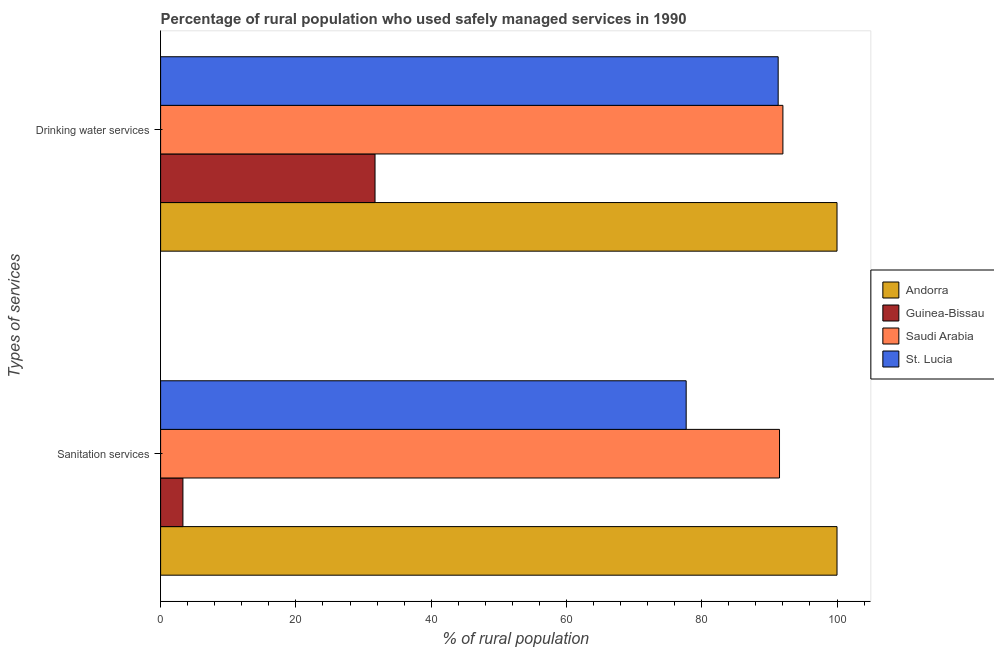How many different coloured bars are there?
Your answer should be very brief. 4. Are the number of bars per tick equal to the number of legend labels?
Provide a short and direct response. Yes. Are the number of bars on each tick of the Y-axis equal?
Keep it short and to the point. Yes. How many bars are there on the 2nd tick from the top?
Offer a very short reply. 4. How many bars are there on the 2nd tick from the bottom?
Your answer should be compact. 4. What is the label of the 1st group of bars from the top?
Your answer should be compact. Drinking water services. What is the percentage of rural population who used drinking water services in St. Lucia?
Provide a succinct answer. 91.3. Across all countries, what is the minimum percentage of rural population who used drinking water services?
Provide a short and direct response. 31.7. In which country was the percentage of rural population who used sanitation services maximum?
Offer a terse response. Andorra. In which country was the percentage of rural population who used sanitation services minimum?
Give a very brief answer. Guinea-Bissau. What is the total percentage of rural population who used sanitation services in the graph?
Give a very brief answer. 272.5. What is the difference between the percentage of rural population who used sanitation services in Andorra and that in Guinea-Bissau?
Your answer should be compact. 96.7. What is the difference between the percentage of rural population who used sanitation services in Saudi Arabia and the percentage of rural population who used drinking water services in Guinea-Bissau?
Give a very brief answer. 59.8. What is the average percentage of rural population who used drinking water services per country?
Provide a short and direct response. 78.75. What is the difference between the percentage of rural population who used drinking water services and percentage of rural population who used sanitation services in Saudi Arabia?
Offer a terse response. 0.5. Is the percentage of rural population who used drinking water services in Guinea-Bissau less than that in Saudi Arabia?
Offer a terse response. Yes. What does the 1st bar from the top in Sanitation services represents?
Give a very brief answer. St. Lucia. What does the 4th bar from the bottom in Sanitation services represents?
Offer a very short reply. St. Lucia. How many bars are there?
Keep it short and to the point. 8. Are all the bars in the graph horizontal?
Make the answer very short. Yes. Does the graph contain grids?
Give a very brief answer. No. Where does the legend appear in the graph?
Offer a very short reply. Center right. How are the legend labels stacked?
Ensure brevity in your answer.  Vertical. What is the title of the graph?
Your answer should be very brief. Percentage of rural population who used safely managed services in 1990. What is the label or title of the X-axis?
Offer a terse response. % of rural population. What is the label or title of the Y-axis?
Ensure brevity in your answer.  Types of services. What is the % of rural population of Andorra in Sanitation services?
Provide a short and direct response. 100. What is the % of rural population of Saudi Arabia in Sanitation services?
Keep it short and to the point. 91.5. What is the % of rural population in St. Lucia in Sanitation services?
Give a very brief answer. 77.7. What is the % of rural population of Guinea-Bissau in Drinking water services?
Ensure brevity in your answer.  31.7. What is the % of rural population in Saudi Arabia in Drinking water services?
Provide a succinct answer. 92. What is the % of rural population of St. Lucia in Drinking water services?
Make the answer very short. 91.3. Across all Types of services, what is the maximum % of rural population in Andorra?
Provide a short and direct response. 100. Across all Types of services, what is the maximum % of rural population of Guinea-Bissau?
Your answer should be compact. 31.7. Across all Types of services, what is the maximum % of rural population of Saudi Arabia?
Make the answer very short. 92. Across all Types of services, what is the maximum % of rural population in St. Lucia?
Keep it short and to the point. 91.3. Across all Types of services, what is the minimum % of rural population in Guinea-Bissau?
Keep it short and to the point. 3.3. Across all Types of services, what is the minimum % of rural population of Saudi Arabia?
Provide a succinct answer. 91.5. Across all Types of services, what is the minimum % of rural population of St. Lucia?
Offer a very short reply. 77.7. What is the total % of rural population in Andorra in the graph?
Keep it short and to the point. 200. What is the total % of rural population in Saudi Arabia in the graph?
Provide a short and direct response. 183.5. What is the total % of rural population in St. Lucia in the graph?
Give a very brief answer. 169. What is the difference between the % of rural population in Andorra in Sanitation services and that in Drinking water services?
Your answer should be very brief. 0. What is the difference between the % of rural population in Guinea-Bissau in Sanitation services and that in Drinking water services?
Provide a succinct answer. -28.4. What is the difference between the % of rural population in Saudi Arabia in Sanitation services and that in Drinking water services?
Your answer should be very brief. -0.5. What is the difference between the % of rural population of St. Lucia in Sanitation services and that in Drinking water services?
Your response must be concise. -13.6. What is the difference between the % of rural population of Andorra in Sanitation services and the % of rural population of Guinea-Bissau in Drinking water services?
Provide a succinct answer. 68.3. What is the difference between the % of rural population of Andorra in Sanitation services and the % of rural population of Saudi Arabia in Drinking water services?
Your response must be concise. 8. What is the difference between the % of rural population of Andorra in Sanitation services and the % of rural population of St. Lucia in Drinking water services?
Your answer should be compact. 8.7. What is the difference between the % of rural population of Guinea-Bissau in Sanitation services and the % of rural population of Saudi Arabia in Drinking water services?
Offer a very short reply. -88.7. What is the difference between the % of rural population in Guinea-Bissau in Sanitation services and the % of rural population in St. Lucia in Drinking water services?
Your answer should be compact. -88. What is the difference between the % of rural population of Saudi Arabia in Sanitation services and the % of rural population of St. Lucia in Drinking water services?
Provide a succinct answer. 0.2. What is the average % of rural population in Andorra per Types of services?
Ensure brevity in your answer.  100. What is the average % of rural population of Guinea-Bissau per Types of services?
Provide a succinct answer. 17.5. What is the average % of rural population in Saudi Arabia per Types of services?
Offer a terse response. 91.75. What is the average % of rural population in St. Lucia per Types of services?
Make the answer very short. 84.5. What is the difference between the % of rural population in Andorra and % of rural population in Guinea-Bissau in Sanitation services?
Provide a short and direct response. 96.7. What is the difference between the % of rural population of Andorra and % of rural population of Saudi Arabia in Sanitation services?
Keep it short and to the point. 8.5. What is the difference between the % of rural population of Andorra and % of rural population of St. Lucia in Sanitation services?
Your response must be concise. 22.3. What is the difference between the % of rural population in Guinea-Bissau and % of rural population in Saudi Arabia in Sanitation services?
Give a very brief answer. -88.2. What is the difference between the % of rural population in Guinea-Bissau and % of rural population in St. Lucia in Sanitation services?
Your answer should be compact. -74.4. What is the difference between the % of rural population of Andorra and % of rural population of Guinea-Bissau in Drinking water services?
Make the answer very short. 68.3. What is the difference between the % of rural population in Guinea-Bissau and % of rural population in Saudi Arabia in Drinking water services?
Your answer should be compact. -60.3. What is the difference between the % of rural population in Guinea-Bissau and % of rural population in St. Lucia in Drinking water services?
Your answer should be very brief. -59.6. What is the ratio of the % of rural population of Guinea-Bissau in Sanitation services to that in Drinking water services?
Give a very brief answer. 0.1. What is the ratio of the % of rural population in Saudi Arabia in Sanitation services to that in Drinking water services?
Offer a very short reply. 0.99. What is the ratio of the % of rural population of St. Lucia in Sanitation services to that in Drinking water services?
Your answer should be compact. 0.85. What is the difference between the highest and the second highest % of rural population in Andorra?
Give a very brief answer. 0. What is the difference between the highest and the second highest % of rural population of Guinea-Bissau?
Offer a terse response. 28.4. What is the difference between the highest and the second highest % of rural population in Saudi Arabia?
Offer a very short reply. 0.5. What is the difference between the highest and the lowest % of rural population in Andorra?
Your answer should be very brief. 0. What is the difference between the highest and the lowest % of rural population of Guinea-Bissau?
Your response must be concise. 28.4. What is the difference between the highest and the lowest % of rural population in Saudi Arabia?
Offer a very short reply. 0.5. What is the difference between the highest and the lowest % of rural population in St. Lucia?
Your answer should be compact. 13.6. 